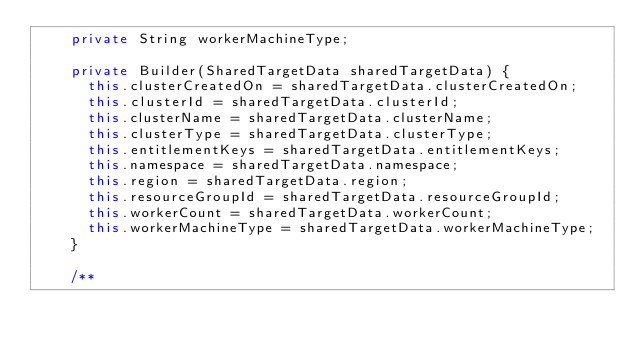Convert code to text. <code><loc_0><loc_0><loc_500><loc_500><_Java_>    private String workerMachineType;

    private Builder(SharedTargetData sharedTargetData) {
      this.clusterCreatedOn = sharedTargetData.clusterCreatedOn;
      this.clusterId = sharedTargetData.clusterId;
      this.clusterName = sharedTargetData.clusterName;
      this.clusterType = sharedTargetData.clusterType;
      this.entitlementKeys = sharedTargetData.entitlementKeys;
      this.namespace = sharedTargetData.namespace;
      this.region = sharedTargetData.region;
      this.resourceGroupId = sharedTargetData.resourceGroupId;
      this.workerCount = sharedTargetData.workerCount;
      this.workerMachineType = sharedTargetData.workerMachineType;
    }

    /**</code> 